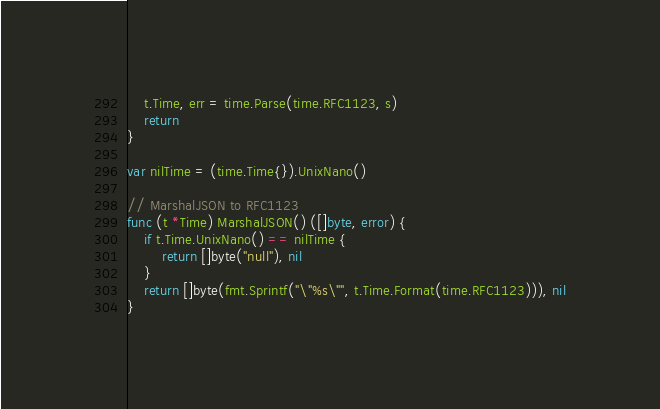Convert code to text. <code><loc_0><loc_0><loc_500><loc_500><_Go_>	t.Time, err = time.Parse(time.RFC1123, s)
	return
}

var nilTime = (time.Time{}).UnixNano()

// MarshalJSON to RFC1123
func (t *Time) MarshalJSON() ([]byte, error) {
	if t.Time.UnixNano() == nilTime {
		return []byte("null"), nil
	}
	return []byte(fmt.Sprintf("\"%s\"", t.Time.Format(time.RFC1123))), nil
}
</code> 